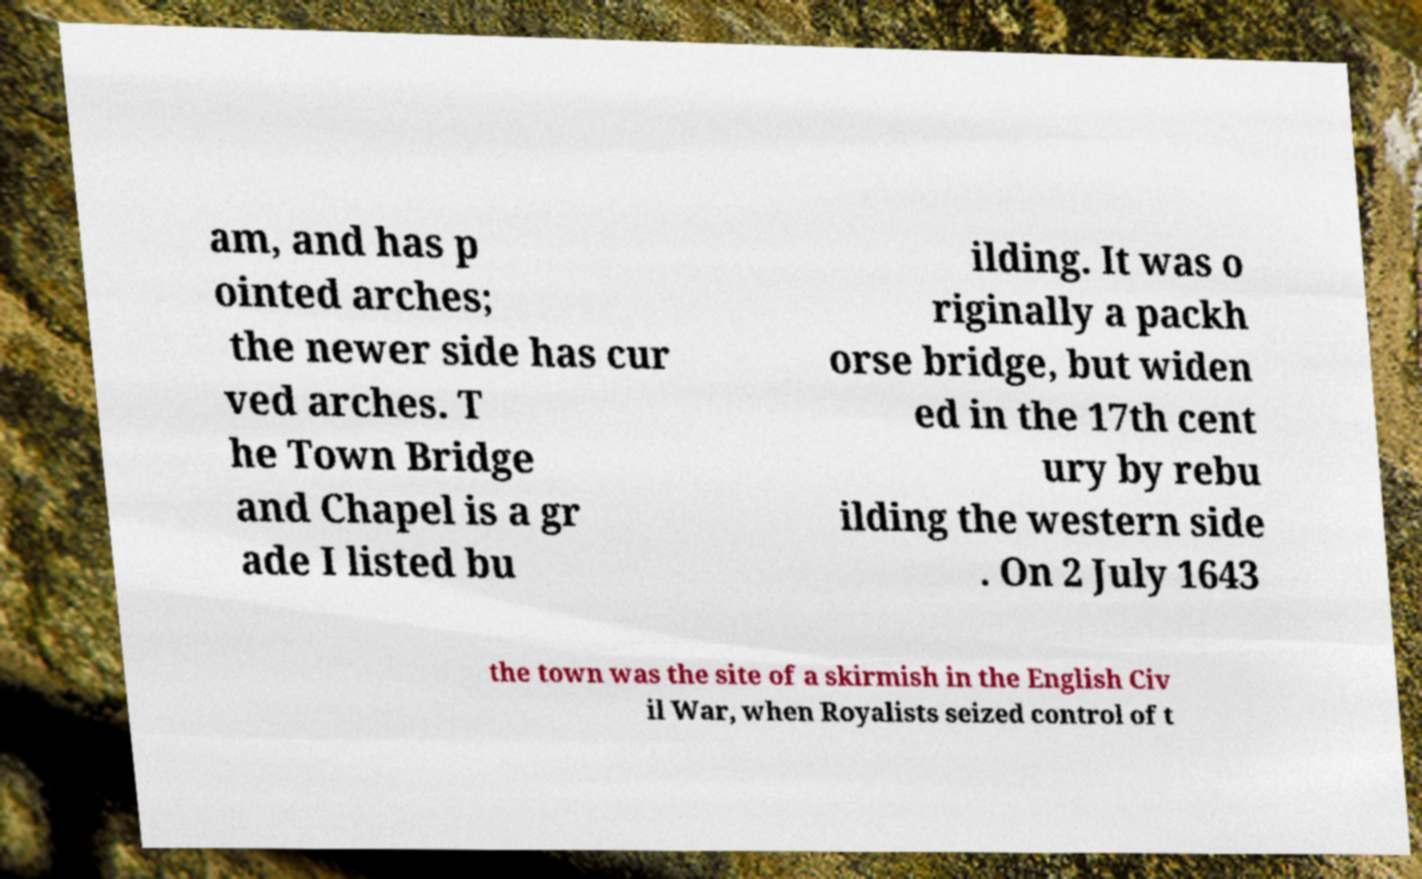For documentation purposes, I need the text within this image transcribed. Could you provide that? am, and has p ointed arches; the newer side has cur ved arches. T he Town Bridge and Chapel is a gr ade I listed bu ilding. It was o riginally a packh orse bridge, but widen ed in the 17th cent ury by rebu ilding the western side . On 2 July 1643 the town was the site of a skirmish in the English Civ il War, when Royalists seized control of t 